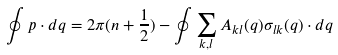Convert formula to latex. <formula><loc_0><loc_0><loc_500><loc_500>\oint { { p } \cdot d { q } } = 2 \pi ( n + \frac { 1 } { 2 } ) - \oint { \sum _ { k , l } { { A } _ { k l } ( { q } ) \sigma _ { l k } ( { q } ) } \cdot d { q } }</formula> 